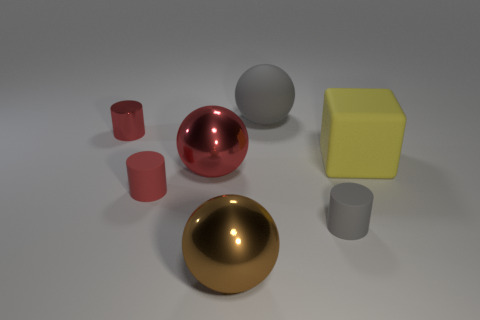Subtract all gray spheres. How many spheres are left? 2 Subtract all cylinders. How many objects are left? 4 Subtract all gray spheres. How many spheres are left? 2 Add 1 large yellow things. How many large yellow things exist? 2 Add 2 gray matte cylinders. How many objects exist? 9 Subtract 1 yellow blocks. How many objects are left? 6 Subtract 1 cubes. How many cubes are left? 0 Subtract all cyan cylinders. Subtract all red balls. How many cylinders are left? 3 Subtract all yellow spheres. How many gray cylinders are left? 1 Subtract all blue metal cylinders. Subtract all large rubber things. How many objects are left? 5 